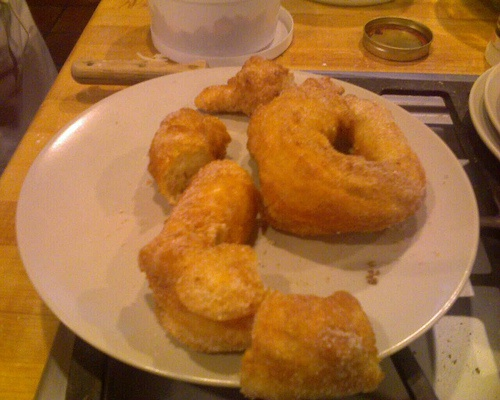Describe the objects in this image and their specific colors. I can see dining table in red, tan, orange, and maroon tones, donut in maroon, red, and orange tones, donut in maroon, brown, orange, and tan tones, donut in maroon, red, and orange tones, and cup in maroon, gray, tan, olive, and orange tones in this image. 